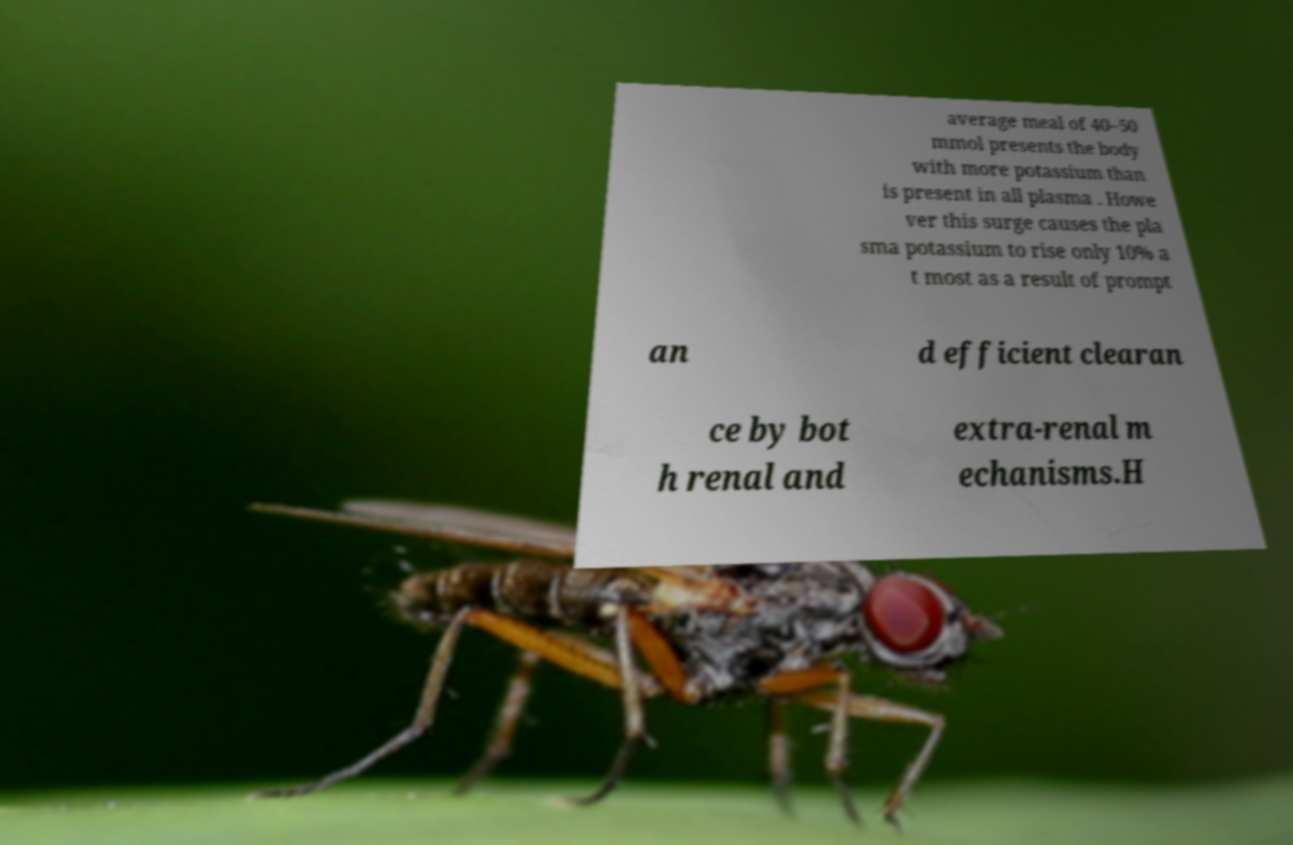Can you accurately transcribe the text from the provided image for me? average meal of 40–50 mmol presents the body with more potassium than is present in all plasma . Howe ver this surge causes the pla sma potassium to rise only 10% a t most as a result of prompt an d efficient clearan ce by bot h renal and extra-renal m echanisms.H 